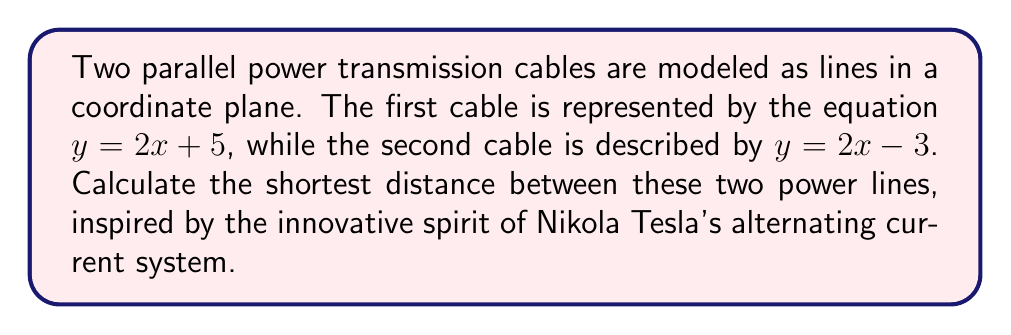Solve this math problem. Let's approach this step-by-step:

1) The general equation for the shortest distance $d$ between two parallel lines $ax + by + c_1 = 0$ and $ax + by + c_2 = 0$ is:

   $$d = \frac{|c_1 - c_2|}{\sqrt{a^2 + b^2}}$$

2) We need to convert our lines into the general form $ax + by + c = 0$:
   
   Line 1: $y = 2x + 5$ becomes $-2x + y - 5 = 0$
   Line 2: $y = 2x - 3$ becomes $-2x + y + 3 = 0$

3) Comparing with the general form, we see that:
   $a = -2$, $b = 1$, $c_1 = -5$, and $c_2 = 3$

4) Now we can substitute these values into our distance formula:

   $$d = \frac{|c_1 - c_2|}{\sqrt{a^2 + b^2}} = \frac{|-5 - 3|}{\sqrt{(-2)^2 + 1^2}}$$

5) Simplify:
   $$d = \frac{|-8|}{\sqrt{4 + 1}} = \frac{8}{\sqrt{5}}$$

6) This can be further simplified:
   $$d = \frac{8}{\sqrt{5}} = \frac{8\sqrt{5}}{5}$$

Thus, the shortest distance between the two power transmission cables is $\frac{8\sqrt{5}}{5}$ units.

[asy]
import geometry;

size(200);
real m = 2;
real b1 = 5;
real b2 = -3;

pair A1 = (-2,m*(-2)+b1);
pair B1 = (2,m*2+b1);
pair A2 = (-2,m*(-2)+b2);
pair B2 = (2,m*2+b2);

draw(A1--B1, blue);
draw(A2--B2, red);

label("$y = 2x + 5$", B1, NE, blue);
label("$y = 2x - 3$", B2, SE, red);

pair P1 = (0,b1);
pair P2 = (0,b2);

draw(P1--P2, dashed);
label("$\frac{8\sqrt{5}}{5}$", (P1+P2)/2, E);
[/asy]
Answer: $\frac{8\sqrt{5}}{5}$ units 